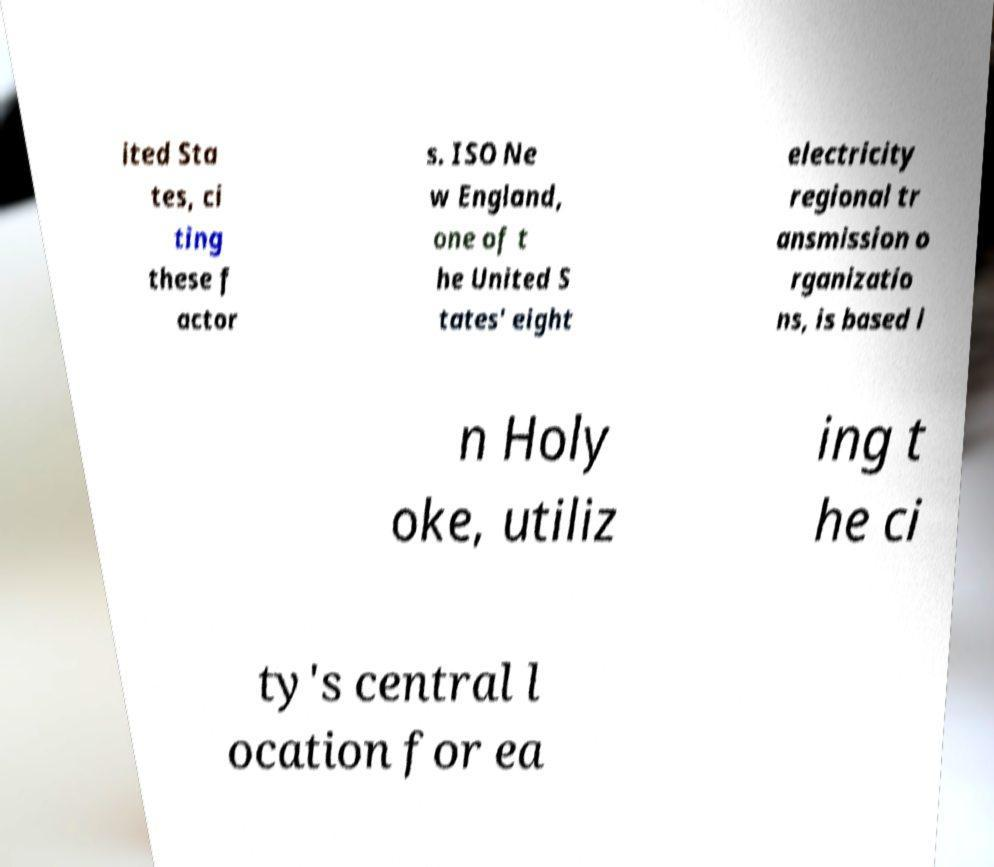Please identify and transcribe the text found in this image. ited Sta tes, ci ting these f actor s. ISO Ne w England, one of t he United S tates' eight electricity regional tr ansmission o rganizatio ns, is based i n Holy oke, utiliz ing t he ci ty's central l ocation for ea 